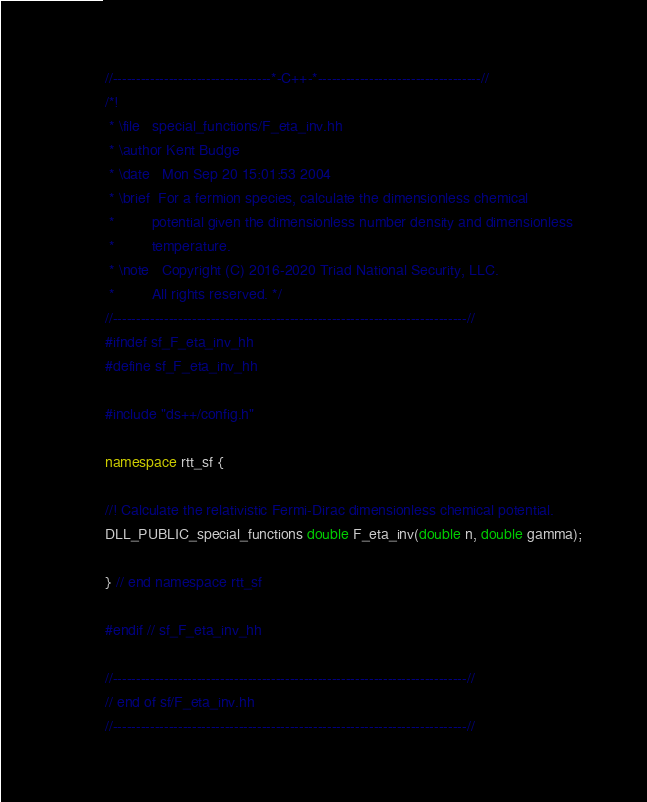Convert code to text. <code><loc_0><loc_0><loc_500><loc_500><_C++_>//----------------------------------*-C++-*-----------------------------------//
/*!
 * \file   special_functions/F_eta_inv.hh
 * \author Kent Budge
 * \date   Mon Sep 20 15:01:53 2004
 * \brief  For a fermion species, calculate the dimensionless chemical 
 *         potential given the dimensionless number density and dimensionless
 *         temperature.  
 * \note   Copyright (C) 2016-2020 Triad National Security, LLC.
 *         All rights reserved. */
//----------------------------------------------------------------------------//
#ifndef sf_F_eta_inv_hh
#define sf_F_eta_inv_hh

#include "ds++/config.h"

namespace rtt_sf {

//! Calculate the relativistic Fermi-Dirac dimensionless chemical potential.
DLL_PUBLIC_special_functions double F_eta_inv(double n, double gamma);

} // end namespace rtt_sf

#endif // sf_F_eta_inv_hh

//----------------------------------------------------------------------------//
// end of sf/F_eta_inv.hh
//----------------------------------------------------------------------------//
</code> 